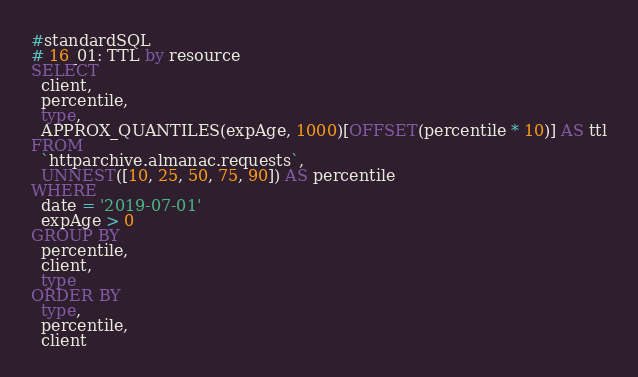<code> <loc_0><loc_0><loc_500><loc_500><_SQL_>#standardSQL
# 16_01: TTL by resource
SELECT
  client,
  percentile,
  type,
  APPROX_QUANTILES(expAge, 1000)[OFFSET(percentile * 10)] AS ttl
FROM
  `httparchive.almanac.requests`,
  UNNEST([10, 25, 50, 75, 90]) AS percentile
WHERE
  date = '2019-07-01'
  expAge > 0
GROUP BY
  percentile,
  client,
  type
ORDER BY
  type,
  percentile,
  client
</code> 